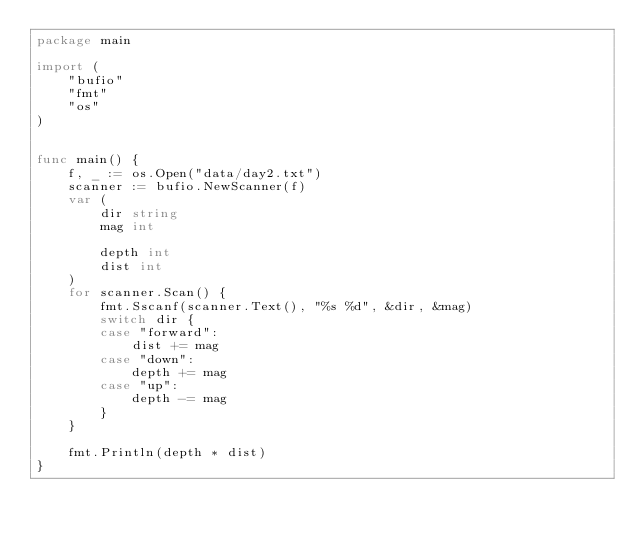<code> <loc_0><loc_0><loc_500><loc_500><_Go_>package main

import (
	"bufio"
	"fmt"
	"os"
)


func main() {
	f, _ := os.Open("data/day2.txt")
	scanner := bufio.NewScanner(f)
	var (
		dir string
		mag int

		depth int
		dist int
	)
	for scanner.Scan() {
		fmt.Sscanf(scanner.Text(), "%s %d", &dir, &mag)
		switch dir {
		case "forward":
			dist += mag
		case "down":
			depth += mag
		case "up":
			depth -= mag
		}
	}

	fmt.Println(depth * dist)
}</code> 